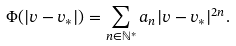Convert formula to latex. <formula><loc_0><loc_0><loc_500><loc_500>\Phi ( | v - v _ { * } | ) = \sum _ { n \in \mathbb { N } ^ { * } } a _ { n } | v - v _ { * } | ^ { 2 n } .</formula> 